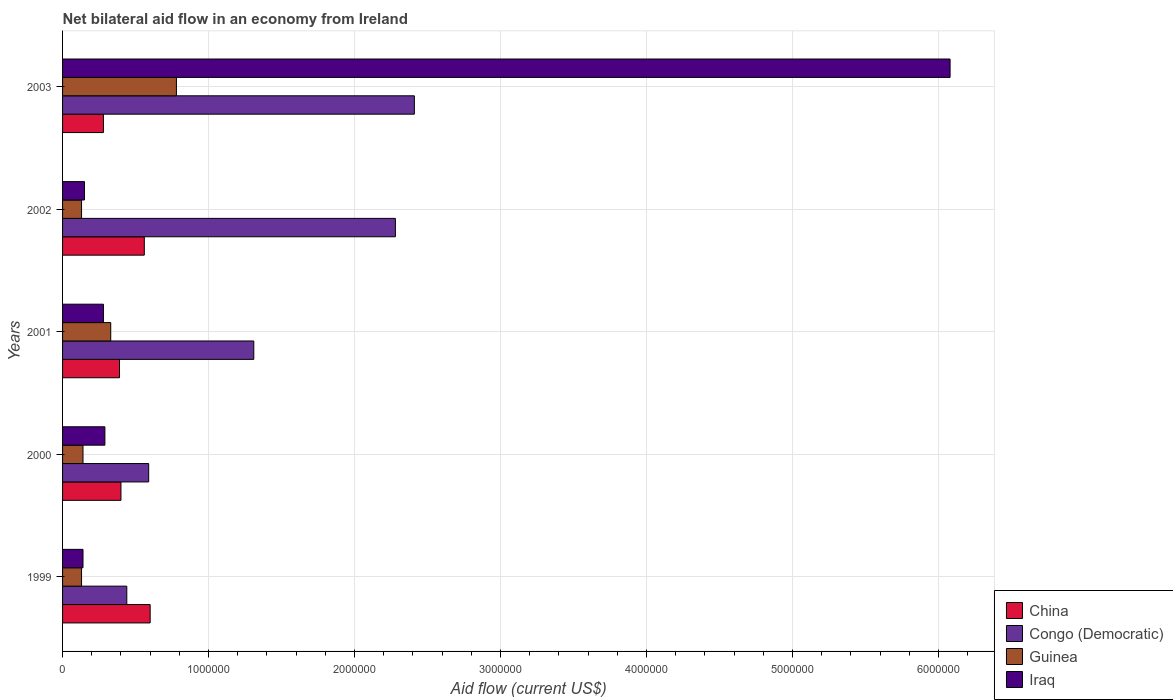Are the number of bars per tick equal to the number of legend labels?
Offer a terse response. Yes. How many bars are there on the 5th tick from the top?
Offer a very short reply. 4. How many bars are there on the 2nd tick from the bottom?
Provide a succinct answer. 4. In how many cases, is the number of bars for a given year not equal to the number of legend labels?
Offer a terse response. 0. What is the net bilateral aid flow in China in 1999?
Your response must be concise. 6.00e+05. Across all years, what is the maximum net bilateral aid flow in China?
Make the answer very short. 6.00e+05. In which year was the net bilateral aid flow in China maximum?
Your answer should be compact. 1999. What is the total net bilateral aid flow in Congo (Democratic) in the graph?
Your answer should be compact. 7.03e+06. What is the difference between the net bilateral aid flow in Iraq in 1999 and the net bilateral aid flow in Guinea in 2003?
Your answer should be very brief. -6.40e+05. What is the average net bilateral aid flow in Iraq per year?
Provide a succinct answer. 1.39e+06. In how many years, is the net bilateral aid flow in China greater than 3400000 US$?
Give a very brief answer. 0. What is the ratio of the net bilateral aid flow in Iraq in 2000 to that in 2003?
Offer a very short reply. 0.05. Is the net bilateral aid flow in Congo (Democratic) in 2000 less than that in 2001?
Offer a very short reply. Yes. Is the difference between the net bilateral aid flow in China in 2002 and 2003 greater than the difference between the net bilateral aid flow in Guinea in 2002 and 2003?
Offer a very short reply. Yes. What is the difference between the highest and the lowest net bilateral aid flow in Iraq?
Provide a succinct answer. 5.94e+06. Is it the case that in every year, the sum of the net bilateral aid flow in Guinea and net bilateral aid flow in Iraq is greater than the sum of net bilateral aid flow in China and net bilateral aid flow in Congo (Democratic)?
Offer a very short reply. No. What does the 1st bar from the top in 2000 represents?
Give a very brief answer. Iraq. What does the 4th bar from the bottom in 2000 represents?
Provide a short and direct response. Iraq. Is it the case that in every year, the sum of the net bilateral aid flow in Iraq and net bilateral aid flow in Guinea is greater than the net bilateral aid flow in China?
Make the answer very short. No. What is the difference between two consecutive major ticks on the X-axis?
Your answer should be very brief. 1.00e+06. Are the values on the major ticks of X-axis written in scientific E-notation?
Your response must be concise. No. Does the graph contain grids?
Provide a succinct answer. Yes. Where does the legend appear in the graph?
Ensure brevity in your answer.  Bottom right. How many legend labels are there?
Offer a terse response. 4. What is the title of the graph?
Ensure brevity in your answer.  Net bilateral aid flow in an economy from Ireland. Does "Belize" appear as one of the legend labels in the graph?
Your answer should be compact. No. What is the label or title of the X-axis?
Your answer should be very brief. Aid flow (current US$). What is the label or title of the Y-axis?
Provide a succinct answer. Years. What is the Aid flow (current US$) of Congo (Democratic) in 1999?
Give a very brief answer. 4.40e+05. What is the Aid flow (current US$) of Congo (Democratic) in 2000?
Give a very brief answer. 5.90e+05. What is the Aid flow (current US$) of Congo (Democratic) in 2001?
Keep it short and to the point. 1.31e+06. What is the Aid flow (current US$) in Iraq in 2001?
Give a very brief answer. 2.80e+05. What is the Aid flow (current US$) in China in 2002?
Give a very brief answer. 5.60e+05. What is the Aid flow (current US$) of Congo (Democratic) in 2002?
Provide a succinct answer. 2.28e+06. What is the Aid flow (current US$) of Guinea in 2002?
Ensure brevity in your answer.  1.30e+05. What is the Aid flow (current US$) of Iraq in 2002?
Offer a terse response. 1.50e+05. What is the Aid flow (current US$) in Congo (Democratic) in 2003?
Your answer should be compact. 2.41e+06. What is the Aid flow (current US$) of Guinea in 2003?
Offer a terse response. 7.80e+05. What is the Aid flow (current US$) of Iraq in 2003?
Your answer should be very brief. 6.08e+06. Across all years, what is the maximum Aid flow (current US$) in China?
Your response must be concise. 6.00e+05. Across all years, what is the maximum Aid flow (current US$) of Congo (Democratic)?
Your answer should be compact. 2.41e+06. Across all years, what is the maximum Aid flow (current US$) of Guinea?
Keep it short and to the point. 7.80e+05. Across all years, what is the maximum Aid flow (current US$) in Iraq?
Provide a short and direct response. 6.08e+06. Across all years, what is the minimum Aid flow (current US$) in Congo (Democratic)?
Offer a terse response. 4.40e+05. What is the total Aid flow (current US$) in China in the graph?
Offer a terse response. 2.23e+06. What is the total Aid flow (current US$) in Congo (Democratic) in the graph?
Ensure brevity in your answer.  7.03e+06. What is the total Aid flow (current US$) in Guinea in the graph?
Make the answer very short. 1.51e+06. What is the total Aid flow (current US$) in Iraq in the graph?
Keep it short and to the point. 6.94e+06. What is the difference between the Aid flow (current US$) in Congo (Democratic) in 1999 and that in 2000?
Keep it short and to the point. -1.50e+05. What is the difference between the Aid flow (current US$) of China in 1999 and that in 2001?
Offer a terse response. 2.10e+05. What is the difference between the Aid flow (current US$) in Congo (Democratic) in 1999 and that in 2001?
Offer a very short reply. -8.70e+05. What is the difference between the Aid flow (current US$) of Guinea in 1999 and that in 2001?
Provide a succinct answer. -2.00e+05. What is the difference between the Aid flow (current US$) of Congo (Democratic) in 1999 and that in 2002?
Keep it short and to the point. -1.84e+06. What is the difference between the Aid flow (current US$) in China in 1999 and that in 2003?
Make the answer very short. 3.20e+05. What is the difference between the Aid flow (current US$) in Congo (Democratic) in 1999 and that in 2003?
Your answer should be compact. -1.97e+06. What is the difference between the Aid flow (current US$) in Guinea in 1999 and that in 2003?
Ensure brevity in your answer.  -6.50e+05. What is the difference between the Aid flow (current US$) in Iraq in 1999 and that in 2003?
Offer a very short reply. -5.94e+06. What is the difference between the Aid flow (current US$) of China in 2000 and that in 2001?
Offer a very short reply. 10000. What is the difference between the Aid flow (current US$) in Congo (Democratic) in 2000 and that in 2001?
Make the answer very short. -7.20e+05. What is the difference between the Aid flow (current US$) of Guinea in 2000 and that in 2001?
Ensure brevity in your answer.  -1.90e+05. What is the difference between the Aid flow (current US$) of Congo (Democratic) in 2000 and that in 2002?
Your answer should be very brief. -1.69e+06. What is the difference between the Aid flow (current US$) in Congo (Democratic) in 2000 and that in 2003?
Keep it short and to the point. -1.82e+06. What is the difference between the Aid flow (current US$) in Guinea in 2000 and that in 2003?
Your answer should be very brief. -6.40e+05. What is the difference between the Aid flow (current US$) of Iraq in 2000 and that in 2003?
Your answer should be very brief. -5.79e+06. What is the difference between the Aid flow (current US$) in Congo (Democratic) in 2001 and that in 2002?
Offer a terse response. -9.70e+05. What is the difference between the Aid flow (current US$) of Guinea in 2001 and that in 2002?
Your answer should be compact. 2.00e+05. What is the difference between the Aid flow (current US$) of Iraq in 2001 and that in 2002?
Your answer should be compact. 1.30e+05. What is the difference between the Aid flow (current US$) in Congo (Democratic) in 2001 and that in 2003?
Offer a terse response. -1.10e+06. What is the difference between the Aid flow (current US$) in Guinea in 2001 and that in 2003?
Your answer should be compact. -4.50e+05. What is the difference between the Aid flow (current US$) of Iraq in 2001 and that in 2003?
Ensure brevity in your answer.  -5.80e+06. What is the difference between the Aid flow (current US$) of China in 2002 and that in 2003?
Provide a succinct answer. 2.80e+05. What is the difference between the Aid flow (current US$) in Guinea in 2002 and that in 2003?
Provide a succinct answer. -6.50e+05. What is the difference between the Aid flow (current US$) of Iraq in 2002 and that in 2003?
Give a very brief answer. -5.93e+06. What is the difference between the Aid flow (current US$) of China in 1999 and the Aid flow (current US$) of Iraq in 2000?
Offer a terse response. 3.10e+05. What is the difference between the Aid flow (current US$) in Guinea in 1999 and the Aid flow (current US$) in Iraq in 2000?
Offer a very short reply. -1.60e+05. What is the difference between the Aid flow (current US$) of China in 1999 and the Aid flow (current US$) of Congo (Democratic) in 2001?
Ensure brevity in your answer.  -7.10e+05. What is the difference between the Aid flow (current US$) in Guinea in 1999 and the Aid flow (current US$) in Iraq in 2001?
Ensure brevity in your answer.  -1.50e+05. What is the difference between the Aid flow (current US$) in China in 1999 and the Aid flow (current US$) in Congo (Democratic) in 2002?
Your answer should be compact. -1.68e+06. What is the difference between the Aid flow (current US$) of Congo (Democratic) in 1999 and the Aid flow (current US$) of Iraq in 2002?
Offer a very short reply. 2.90e+05. What is the difference between the Aid flow (current US$) of Guinea in 1999 and the Aid flow (current US$) of Iraq in 2002?
Make the answer very short. -2.00e+04. What is the difference between the Aid flow (current US$) of China in 1999 and the Aid flow (current US$) of Congo (Democratic) in 2003?
Your answer should be compact. -1.81e+06. What is the difference between the Aid flow (current US$) in China in 1999 and the Aid flow (current US$) in Iraq in 2003?
Make the answer very short. -5.48e+06. What is the difference between the Aid flow (current US$) in Congo (Democratic) in 1999 and the Aid flow (current US$) in Guinea in 2003?
Keep it short and to the point. -3.40e+05. What is the difference between the Aid flow (current US$) in Congo (Democratic) in 1999 and the Aid flow (current US$) in Iraq in 2003?
Make the answer very short. -5.64e+06. What is the difference between the Aid flow (current US$) of Guinea in 1999 and the Aid flow (current US$) of Iraq in 2003?
Ensure brevity in your answer.  -5.95e+06. What is the difference between the Aid flow (current US$) of China in 2000 and the Aid flow (current US$) of Congo (Democratic) in 2001?
Offer a terse response. -9.10e+05. What is the difference between the Aid flow (current US$) in Guinea in 2000 and the Aid flow (current US$) in Iraq in 2001?
Ensure brevity in your answer.  -1.40e+05. What is the difference between the Aid flow (current US$) in China in 2000 and the Aid flow (current US$) in Congo (Democratic) in 2002?
Offer a terse response. -1.88e+06. What is the difference between the Aid flow (current US$) in China in 2000 and the Aid flow (current US$) in Iraq in 2002?
Provide a short and direct response. 2.50e+05. What is the difference between the Aid flow (current US$) in Congo (Democratic) in 2000 and the Aid flow (current US$) in Iraq in 2002?
Your answer should be compact. 4.40e+05. What is the difference between the Aid flow (current US$) in Guinea in 2000 and the Aid flow (current US$) in Iraq in 2002?
Provide a succinct answer. -10000. What is the difference between the Aid flow (current US$) in China in 2000 and the Aid flow (current US$) in Congo (Democratic) in 2003?
Provide a succinct answer. -2.01e+06. What is the difference between the Aid flow (current US$) of China in 2000 and the Aid flow (current US$) of Guinea in 2003?
Ensure brevity in your answer.  -3.80e+05. What is the difference between the Aid flow (current US$) in China in 2000 and the Aid flow (current US$) in Iraq in 2003?
Ensure brevity in your answer.  -5.68e+06. What is the difference between the Aid flow (current US$) of Congo (Democratic) in 2000 and the Aid flow (current US$) of Iraq in 2003?
Make the answer very short. -5.49e+06. What is the difference between the Aid flow (current US$) of Guinea in 2000 and the Aid flow (current US$) of Iraq in 2003?
Provide a short and direct response. -5.94e+06. What is the difference between the Aid flow (current US$) in China in 2001 and the Aid flow (current US$) in Congo (Democratic) in 2002?
Offer a very short reply. -1.89e+06. What is the difference between the Aid flow (current US$) in Congo (Democratic) in 2001 and the Aid flow (current US$) in Guinea in 2002?
Make the answer very short. 1.18e+06. What is the difference between the Aid flow (current US$) in Congo (Democratic) in 2001 and the Aid flow (current US$) in Iraq in 2002?
Provide a short and direct response. 1.16e+06. What is the difference between the Aid flow (current US$) of China in 2001 and the Aid flow (current US$) of Congo (Democratic) in 2003?
Offer a terse response. -2.02e+06. What is the difference between the Aid flow (current US$) of China in 2001 and the Aid flow (current US$) of Guinea in 2003?
Your response must be concise. -3.90e+05. What is the difference between the Aid flow (current US$) in China in 2001 and the Aid flow (current US$) in Iraq in 2003?
Provide a succinct answer. -5.69e+06. What is the difference between the Aid flow (current US$) in Congo (Democratic) in 2001 and the Aid flow (current US$) in Guinea in 2003?
Your answer should be compact. 5.30e+05. What is the difference between the Aid flow (current US$) in Congo (Democratic) in 2001 and the Aid flow (current US$) in Iraq in 2003?
Your answer should be very brief. -4.77e+06. What is the difference between the Aid flow (current US$) in Guinea in 2001 and the Aid flow (current US$) in Iraq in 2003?
Provide a short and direct response. -5.75e+06. What is the difference between the Aid flow (current US$) of China in 2002 and the Aid flow (current US$) of Congo (Democratic) in 2003?
Offer a terse response. -1.85e+06. What is the difference between the Aid flow (current US$) of China in 2002 and the Aid flow (current US$) of Iraq in 2003?
Provide a succinct answer. -5.52e+06. What is the difference between the Aid flow (current US$) of Congo (Democratic) in 2002 and the Aid flow (current US$) of Guinea in 2003?
Offer a terse response. 1.50e+06. What is the difference between the Aid flow (current US$) in Congo (Democratic) in 2002 and the Aid flow (current US$) in Iraq in 2003?
Make the answer very short. -3.80e+06. What is the difference between the Aid flow (current US$) in Guinea in 2002 and the Aid flow (current US$) in Iraq in 2003?
Your answer should be compact. -5.95e+06. What is the average Aid flow (current US$) in China per year?
Ensure brevity in your answer.  4.46e+05. What is the average Aid flow (current US$) of Congo (Democratic) per year?
Your answer should be compact. 1.41e+06. What is the average Aid flow (current US$) in Guinea per year?
Your answer should be compact. 3.02e+05. What is the average Aid flow (current US$) of Iraq per year?
Provide a short and direct response. 1.39e+06. In the year 1999, what is the difference between the Aid flow (current US$) in China and Aid flow (current US$) in Congo (Democratic)?
Your answer should be very brief. 1.60e+05. In the year 2000, what is the difference between the Aid flow (current US$) in China and Aid flow (current US$) in Congo (Democratic)?
Keep it short and to the point. -1.90e+05. In the year 2000, what is the difference between the Aid flow (current US$) in China and Aid flow (current US$) in Iraq?
Give a very brief answer. 1.10e+05. In the year 2000, what is the difference between the Aid flow (current US$) of Congo (Democratic) and Aid flow (current US$) of Guinea?
Provide a short and direct response. 4.50e+05. In the year 2000, what is the difference between the Aid flow (current US$) in Guinea and Aid flow (current US$) in Iraq?
Your answer should be very brief. -1.50e+05. In the year 2001, what is the difference between the Aid flow (current US$) of China and Aid flow (current US$) of Congo (Democratic)?
Offer a terse response. -9.20e+05. In the year 2001, what is the difference between the Aid flow (current US$) of China and Aid flow (current US$) of Guinea?
Your response must be concise. 6.00e+04. In the year 2001, what is the difference between the Aid flow (current US$) of Congo (Democratic) and Aid flow (current US$) of Guinea?
Offer a very short reply. 9.80e+05. In the year 2001, what is the difference between the Aid flow (current US$) in Congo (Democratic) and Aid flow (current US$) in Iraq?
Provide a succinct answer. 1.03e+06. In the year 2002, what is the difference between the Aid flow (current US$) in China and Aid flow (current US$) in Congo (Democratic)?
Offer a terse response. -1.72e+06. In the year 2002, what is the difference between the Aid flow (current US$) in China and Aid flow (current US$) in Iraq?
Offer a very short reply. 4.10e+05. In the year 2002, what is the difference between the Aid flow (current US$) in Congo (Democratic) and Aid flow (current US$) in Guinea?
Offer a terse response. 2.15e+06. In the year 2002, what is the difference between the Aid flow (current US$) in Congo (Democratic) and Aid flow (current US$) in Iraq?
Give a very brief answer. 2.13e+06. In the year 2003, what is the difference between the Aid flow (current US$) of China and Aid flow (current US$) of Congo (Democratic)?
Provide a succinct answer. -2.13e+06. In the year 2003, what is the difference between the Aid flow (current US$) of China and Aid flow (current US$) of Guinea?
Your answer should be very brief. -5.00e+05. In the year 2003, what is the difference between the Aid flow (current US$) in China and Aid flow (current US$) in Iraq?
Keep it short and to the point. -5.80e+06. In the year 2003, what is the difference between the Aid flow (current US$) of Congo (Democratic) and Aid flow (current US$) of Guinea?
Give a very brief answer. 1.63e+06. In the year 2003, what is the difference between the Aid flow (current US$) in Congo (Democratic) and Aid flow (current US$) in Iraq?
Ensure brevity in your answer.  -3.67e+06. In the year 2003, what is the difference between the Aid flow (current US$) of Guinea and Aid flow (current US$) of Iraq?
Provide a short and direct response. -5.30e+06. What is the ratio of the Aid flow (current US$) of China in 1999 to that in 2000?
Offer a terse response. 1.5. What is the ratio of the Aid flow (current US$) of Congo (Democratic) in 1999 to that in 2000?
Provide a succinct answer. 0.75. What is the ratio of the Aid flow (current US$) in Guinea in 1999 to that in 2000?
Keep it short and to the point. 0.93. What is the ratio of the Aid flow (current US$) of Iraq in 1999 to that in 2000?
Your response must be concise. 0.48. What is the ratio of the Aid flow (current US$) of China in 1999 to that in 2001?
Provide a succinct answer. 1.54. What is the ratio of the Aid flow (current US$) in Congo (Democratic) in 1999 to that in 2001?
Your response must be concise. 0.34. What is the ratio of the Aid flow (current US$) in Guinea in 1999 to that in 2001?
Give a very brief answer. 0.39. What is the ratio of the Aid flow (current US$) of China in 1999 to that in 2002?
Provide a succinct answer. 1.07. What is the ratio of the Aid flow (current US$) in Congo (Democratic) in 1999 to that in 2002?
Your response must be concise. 0.19. What is the ratio of the Aid flow (current US$) of Iraq in 1999 to that in 2002?
Provide a short and direct response. 0.93. What is the ratio of the Aid flow (current US$) in China in 1999 to that in 2003?
Ensure brevity in your answer.  2.14. What is the ratio of the Aid flow (current US$) of Congo (Democratic) in 1999 to that in 2003?
Your answer should be very brief. 0.18. What is the ratio of the Aid flow (current US$) in Guinea in 1999 to that in 2003?
Provide a short and direct response. 0.17. What is the ratio of the Aid flow (current US$) in Iraq in 1999 to that in 2003?
Offer a terse response. 0.02. What is the ratio of the Aid flow (current US$) of China in 2000 to that in 2001?
Provide a succinct answer. 1.03. What is the ratio of the Aid flow (current US$) in Congo (Democratic) in 2000 to that in 2001?
Make the answer very short. 0.45. What is the ratio of the Aid flow (current US$) in Guinea in 2000 to that in 2001?
Offer a terse response. 0.42. What is the ratio of the Aid flow (current US$) of Iraq in 2000 to that in 2001?
Offer a very short reply. 1.04. What is the ratio of the Aid flow (current US$) of Congo (Democratic) in 2000 to that in 2002?
Provide a short and direct response. 0.26. What is the ratio of the Aid flow (current US$) in Iraq in 2000 to that in 2002?
Keep it short and to the point. 1.93. What is the ratio of the Aid flow (current US$) in China in 2000 to that in 2003?
Give a very brief answer. 1.43. What is the ratio of the Aid flow (current US$) in Congo (Democratic) in 2000 to that in 2003?
Provide a short and direct response. 0.24. What is the ratio of the Aid flow (current US$) of Guinea in 2000 to that in 2003?
Give a very brief answer. 0.18. What is the ratio of the Aid flow (current US$) of Iraq in 2000 to that in 2003?
Keep it short and to the point. 0.05. What is the ratio of the Aid flow (current US$) in China in 2001 to that in 2002?
Your answer should be very brief. 0.7. What is the ratio of the Aid flow (current US$) in Congo (Democratic) in 2001 to that in 2002?
Give a very brief answer. 0.57. What is the ratio of the Aid flow (current US$) of Guinea in 2001 to that in 2002?
Offer a terse response. 2.54. What is the ratio of the Aid flow (current US$) in Iraq in 2001 to that in 2002?
Your response must be concise. 1.87. What is the ratio of the Aid flow (current US$) of China in 2001 to that in 2003?
Give a very brief answer. 1.39. What is the ratio of the Aid flow (current US$) of Congo (Democratic) in 2001 to that in 2003?
Your answer should be compact. 0.54. What is the ratio of the Aid flow (current US$) of Guinea in 2001 to that in 2003?
Your response must be concise. 0.42. What is the ratio of the Aid flow (current US$) of Iraq in 2001 to that in 2003?
Ensure brevity in your answer.  0.05. What is the ratio of the Aid flow (current US$) of Congo (Democratic) in 2002 to that in 2003?
Ensure brevity in your answer.  0.95. What is the ratio of the Aid flow (current US$) in Iraq in 2002 to that in 2003?
Provide a succinct answer. 0.02. What is the difference between the highest and the second highest Aid flow (current US$) in Congo (Democratic)?
Provide a short and direct response. 1.30e+05. What is the difference between the highest and the second highest Aid flow (current US$) in Guinea?
Your response must be concise. 4.50e+05. What is the difference between the highest and the second highest Aid flow (current US$) in Iraq?
Your answer should be compact. 5.79e+06. What is the difference between the highest and the lowest Aid flow (current US$) of Congo (Democratic)?
Your answer should be compact. 1.97e+06. What is the difference between the highest and the lowest Aid flow (current US$) in Guinea?
Ensure brevity in your answer.  6.50e+05. What is the difference between the highest and the lowest Aid flow (current US$) of Iraq?
Provide a succinct answer. 5.94e+06. 